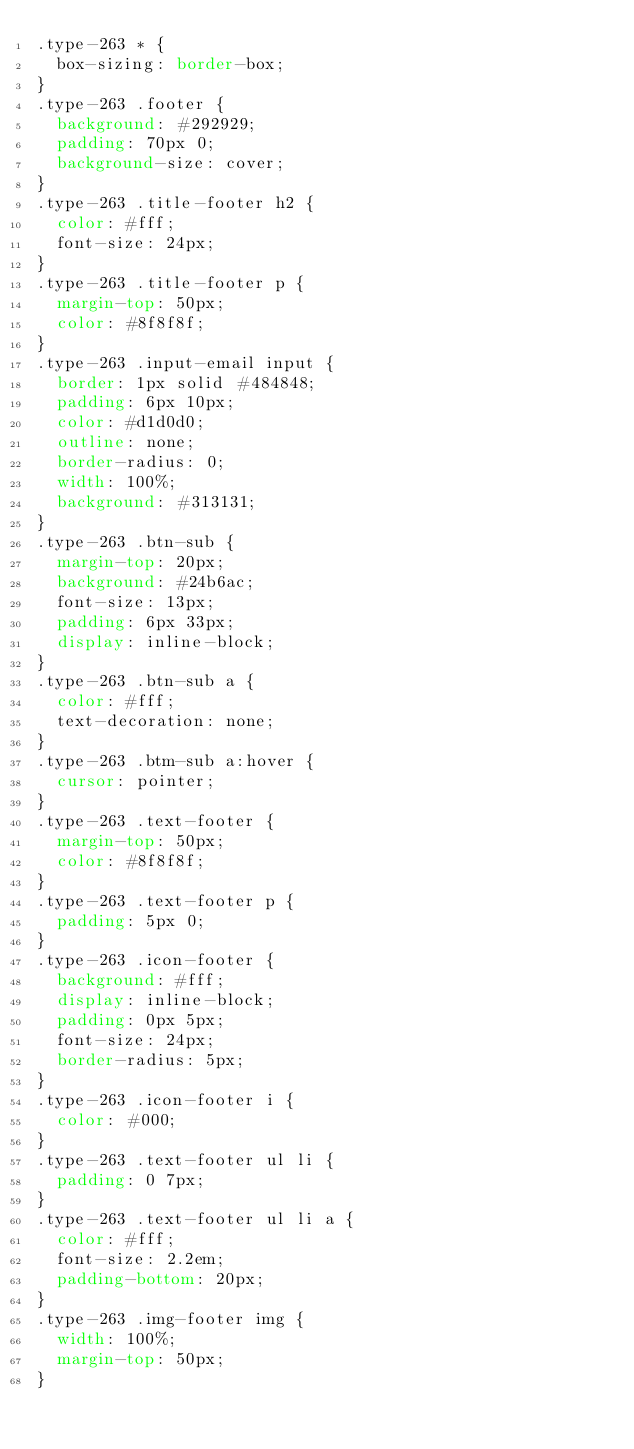<code> <loc_0><loc_0><loc_500><loc_500><_CSS_>.type-263 * {
  box-sizing: border-box;
}
.type-263 .footer {
  background: #292929;
  padding: 70px 0;
  background-size: cover;
}
.type-263 .title-footer h2 {
  color: #fff;
  font-size: 24px;
}
.type-263 .title-footer p {
  margin-top: 50px;
  color: #8f8f8f;
}
.type-263 .input-email input {
  border: 1px solid #484848;
  padding: 6px 10px;
  color: #d1d0d0;
  outline: none;
  border-radius: 0;
  width: 100%;
  background: #313131;
}
.type-263 .btn-sub {
  margin-top: 20px;
  background: #24b6ac;
  font-size: 13px;
  padding: 6px 33px;
  display: inline-block;
}
.type-263 .btn-sub a {
  color: #fff;
  text-decoration: none;
}
.type-263 .btm-sub a:hover {
  cursor: pointer;
}
.type-263 .text-footer {
  margin-top: 50px;
  color: #8f8f8f;
}
.type-263 .text-footer p {
  padding: 5px 0;
}
.type-263 .icon-footer {
  background: #fff;
  display: inline-block;
  padding: 0px 5px;
  font-size: 24px;
  border-radius: 5px;
}
.type-263 .icon-footer i {
  color: #000;
}
.type-263 .text-footer ul li {
  padding: 0 7px;
}
.type-263 .text-footer ul li a {
  color: #fff;
  font-size: 2.2em;
  padding-bottom: 20px;
}
.type-263 .img-footer img {
  width: 100%;
  margin-top: 50px;
}
</code> 